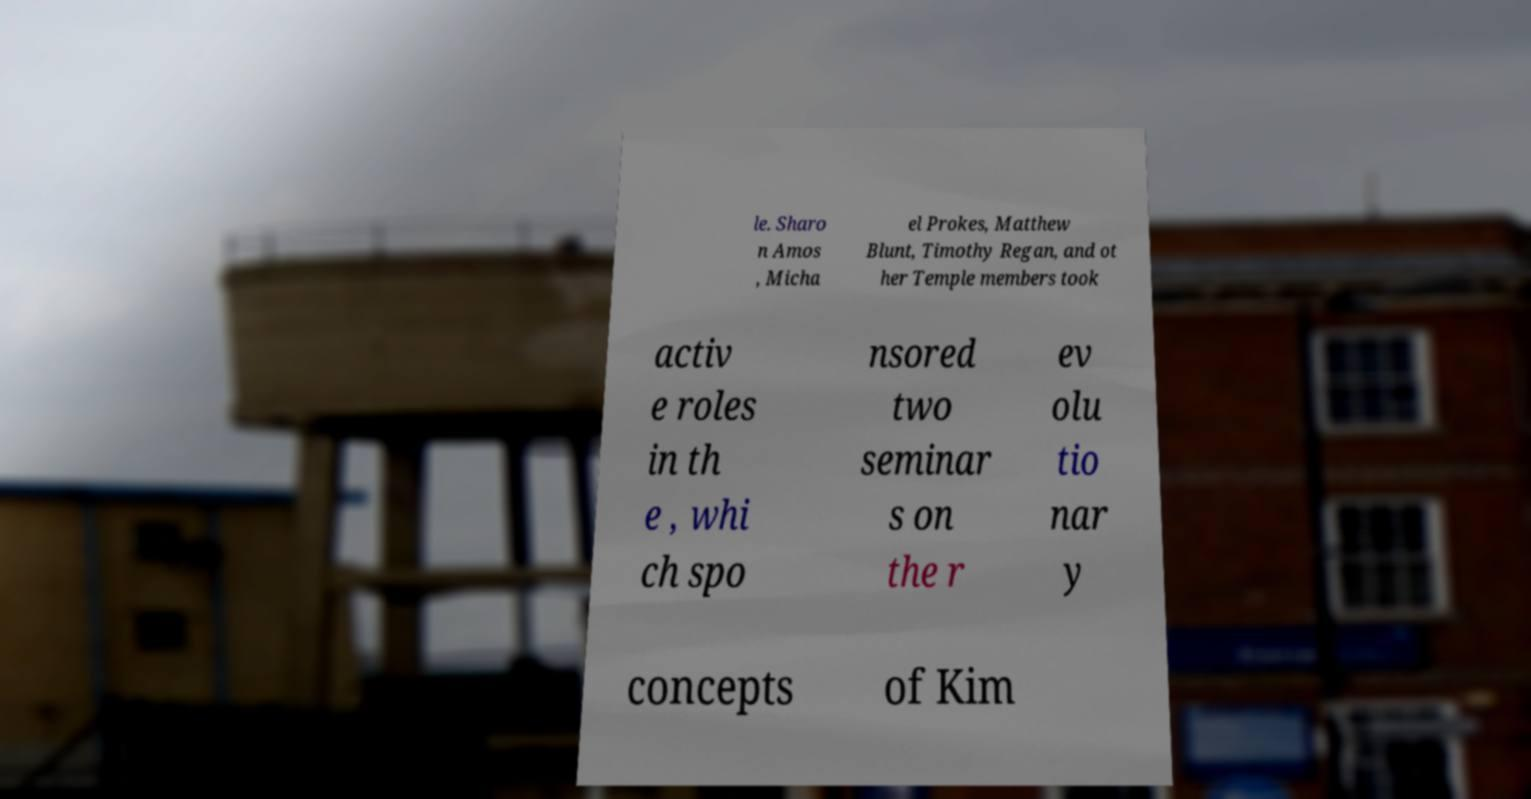Could you assist in decoding the text presented in this image and type it out clearly? le. Sharo n Amos , Micha el Prokes, Matthew Blunt, Timothy Regan, and ot her Temple members took activ e roles in th e , whi ch spo nsored two seminar s on the r ev olu tio nar y concepts of Kim 